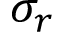Convert formula to latex. <formula><loc_0><loc_0><loc_500><loc_500>\sigma _ { r }</formula> 